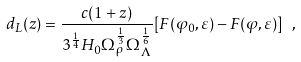Convert formula to latex. <formula><loc_0><loc_0><loc_500><loc_500>d _ { L } ( z ) = \frac { c ( 1 + z ) } { 3 ^ { \frac { 1 } { 4 } } H _ { 0 } \Omega _ { \rho } ^ { \frac { 1 } { 3 } } \Omega _ { \Lambda } ^ { \frac { 1 } { 6 } } } [ F ( \varphi _ { 0 } , \varepsilon ) - F ( \varphi , \varepsilon ) ] \ ,</formula> 